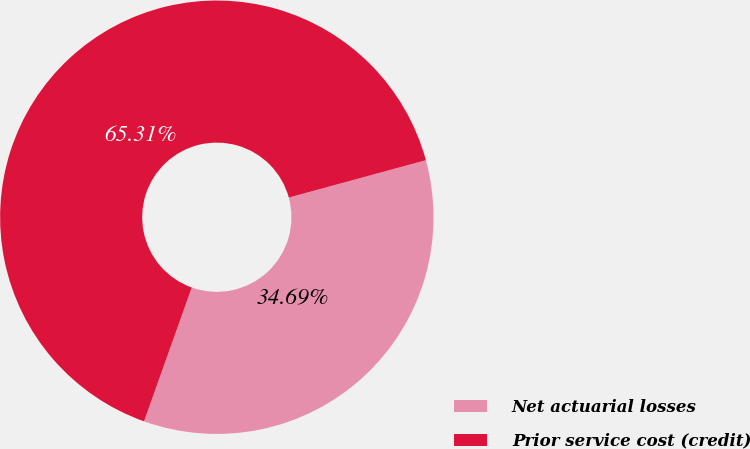Convert chart. <chart><loc_0><loc_0><loc_500><loc_500><pie_chart><fcel>Net actuarial losses<fcel>Prior service cost (credit)<nl><fcel>34.69%<fcel>65.31%<nl></chart> 